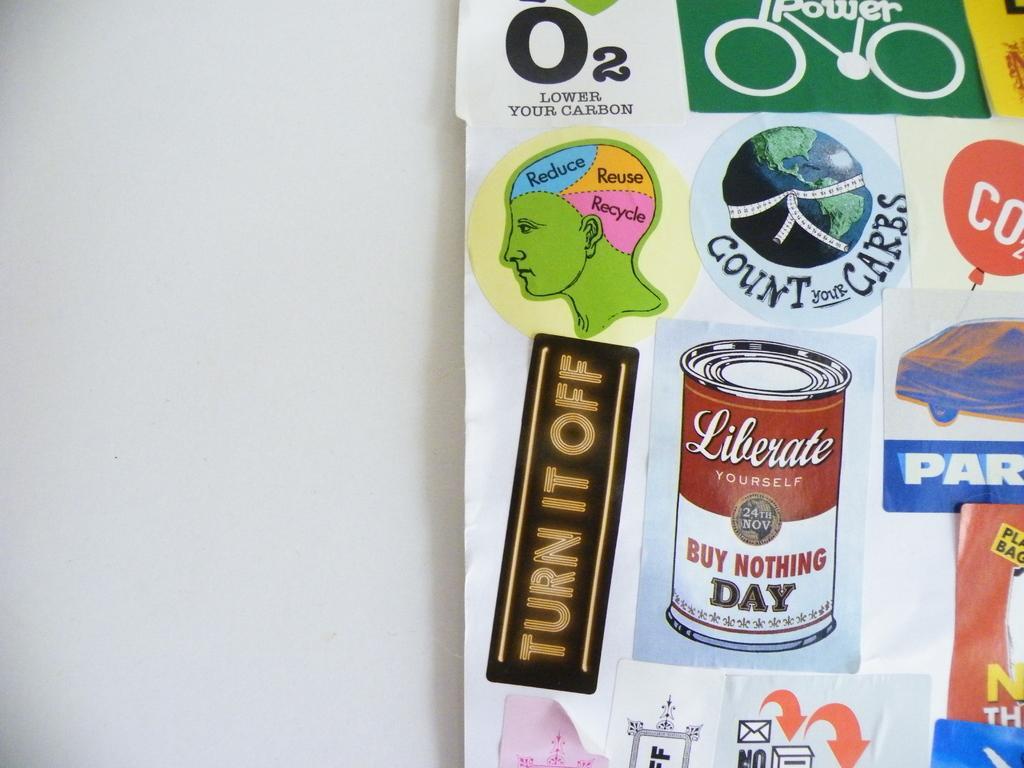How would you summarize this image in a sentence or two? Here in this picture we can see a chart present on the wall over there and we can see number of images on the chart over there. 